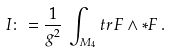Convert formula to latex. <formula><loc_0><loc_0><loc_500><loc_500>I \colon = \frac { 1 } { g ^ { 2 } } \, \int _ { M _ { 4 } } t r \, F \wedge * F \, .</formula> 